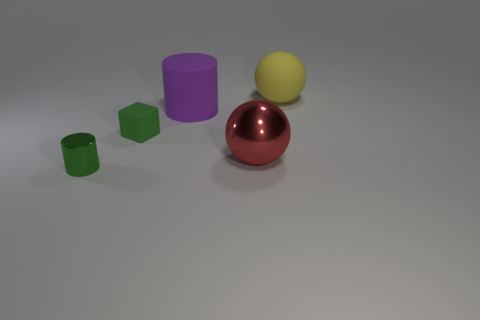There is a red ball; is its size the same as the thing that is to the right of the big metal sphere?
Give a very brief answer. Yes. There is a large thing that is both on the right side of the purple matte cylinder and left of the large yellow ball; what is its shape?
Your answer should be compact. Sphere. How many large things are yellow rubber objects or green shiny cubes?
Offer a terse response. 1. Are there the same number of matte cylinders right of the large red metal sphere and purple rubber cylinders that are in front of the big purple cylinder?
Your answer should be compact. Yes. What number of other objects are there of the same color as the large metal sphere?
Provide a succinct answer. 0. Are there the same number of red metal objects on the right side of the yellow rubber ball and yellow rubber spheres?
Your answer should be compact. No. Do the purple object and the cube have the same size?
Your answer should be compact. No. The thing that is on the right side of the green rubber thing and in front of the small block is made of what material?
Provide a succinct answer. Metal. How many tiny green things are the same shape as the large purple object?
Provide a succinct answer. 1. There is a large thing that is in front of the big cylinder; what material is it?
Give a very brief answer. Metal. 